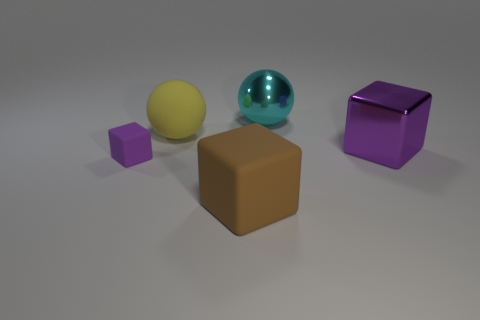Is the number of large purple things on the left side of the large purple thing less than the number of small rubber objects?
Make the answer very short. Yes. There is a big ball that is behind the rubber ball; what number of things are behind it?
Make the answer very short. 0. How big is the object that is both in front of the big purple thing and on the right side of the large yellow thing?
Keep it short and to the point. Large. Are there any other things that have the same material as the cyan ball?
Keep it short and to the point. Yes. Is the small purple block made of the same material as the big thing that is behind the matte sphere?
Your answer should be very brief. No. Are there fewer small matte objects on the right side of the cyan metallic object than big metal blocks behind the large matte ball?
Your response must be concise. No. What is the material of the object to the left of the yellow matte sphere?
Offer a terse response. Rubber. There is a object that is both left of the metal sphere and behind the tiny purple rubber object; what is its color?
Your answer should be very brief. Yellow. What number of other things are the same color as the small cube?
Ensure brevity in your answer.  1. There is a large thing left of the big brown object; what color is it?
Ensure brevity in your answer.  Yellow. 